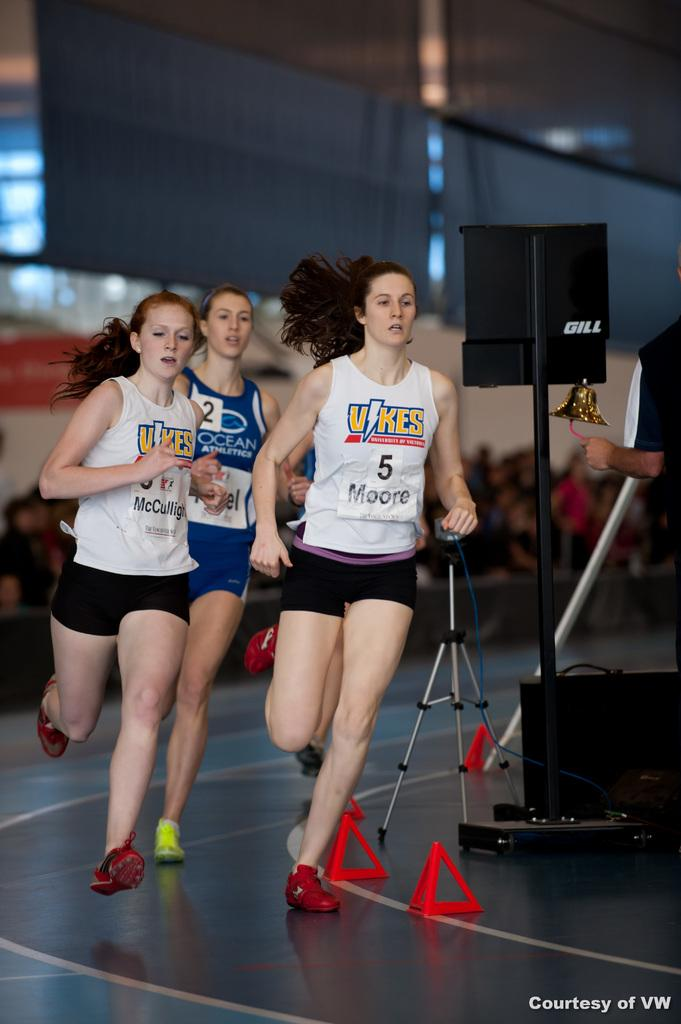<image>
Provide a brief description of the given image. Two female runners on the Vikes team are running a race and are ahead of the female wearing an Ocean Athletic shirt. 